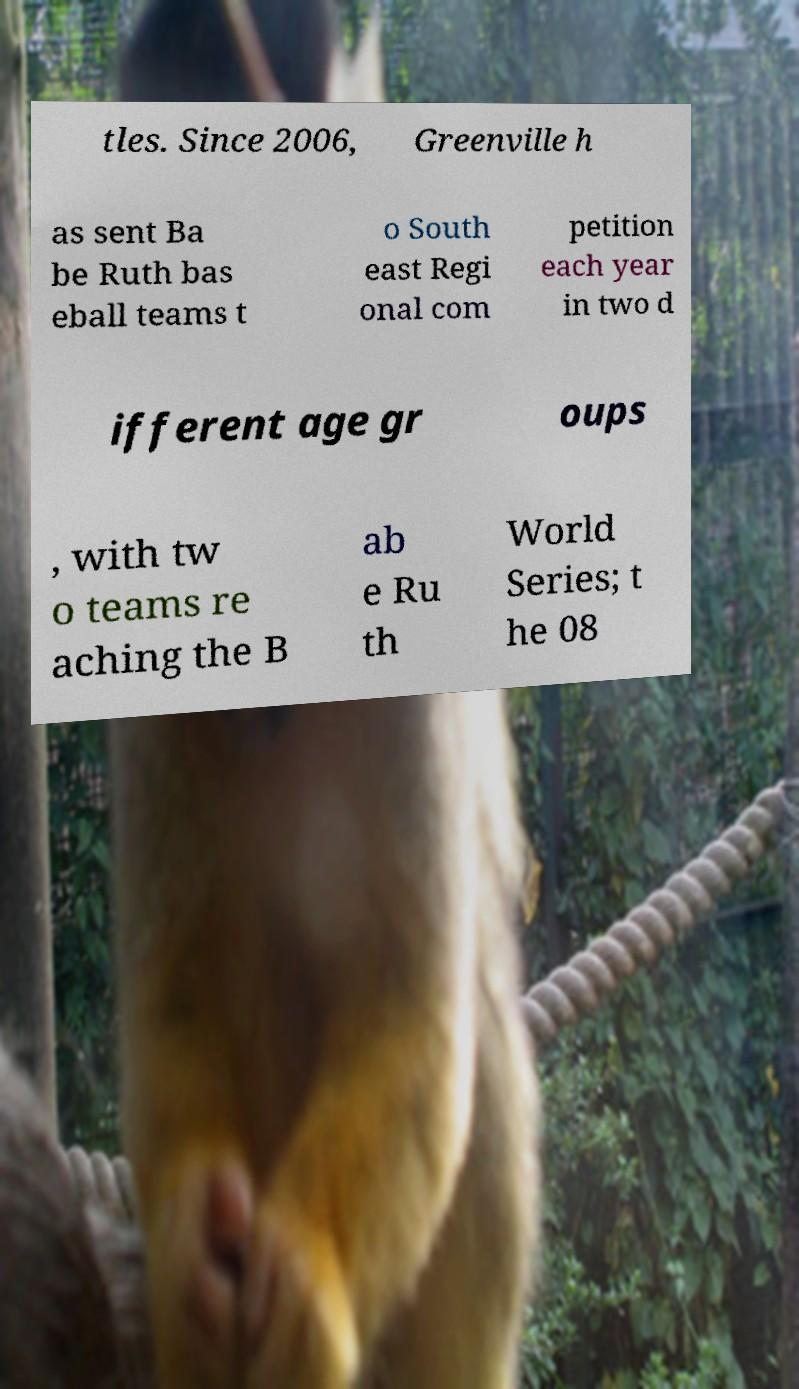Please read and relay the text visible in this image. What does it say? tles. Since 2006, Greenville h as sent Ba be Ruth bas eball teams t o South east Regi onal com petition each year in two d ifferent age gr oups , with tw o teams re aching the B ab e Ru th World Series; t he 08 